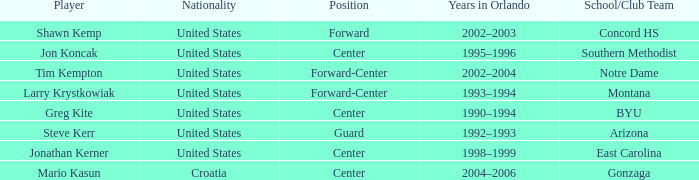What nationality has jon koncak as the player? United States. 